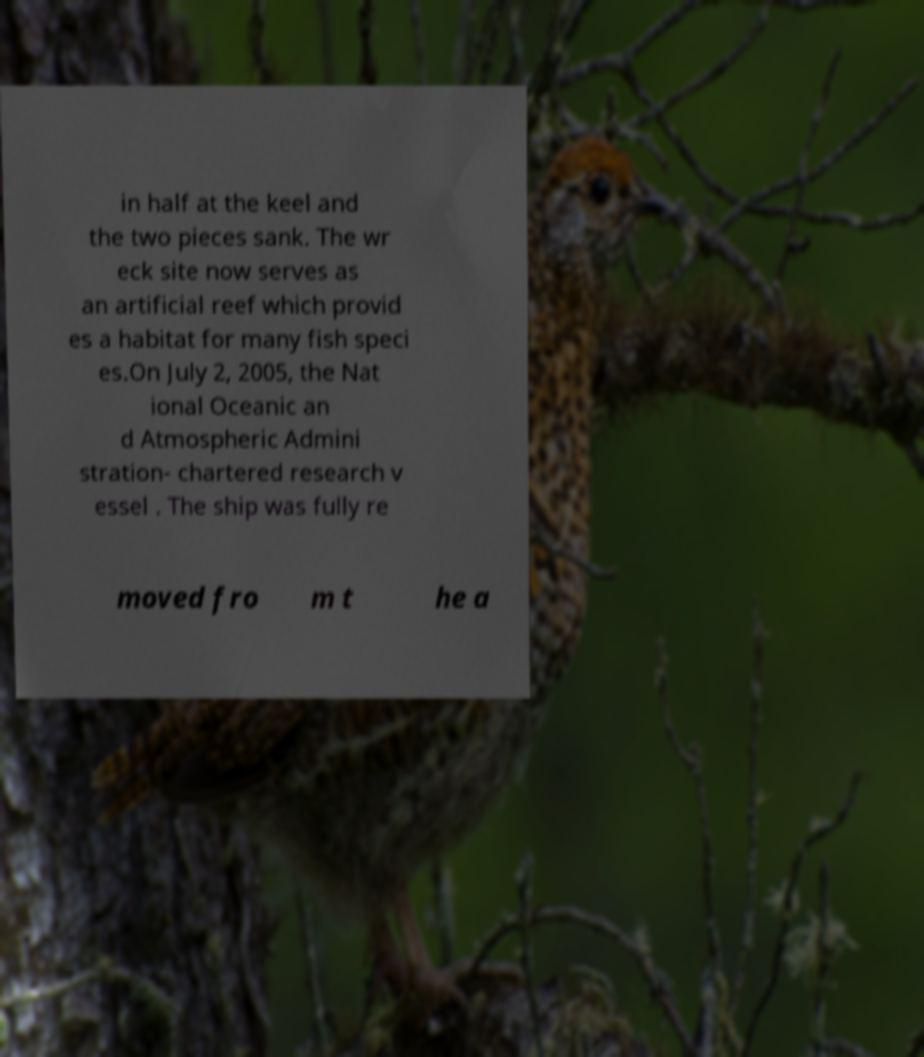What messages or text are displayed in this image? I need them in a readable, typed format. in half at the keel and the two pieces sank. The wr eck site now serves as an artificial reef which provid es a habitat for many fish speci es.On July 2, 2005, the Nat ional Oceanic an d Atmospheric Admini stration- chartered research v essel . The ship was fully re moved fro m t he a 